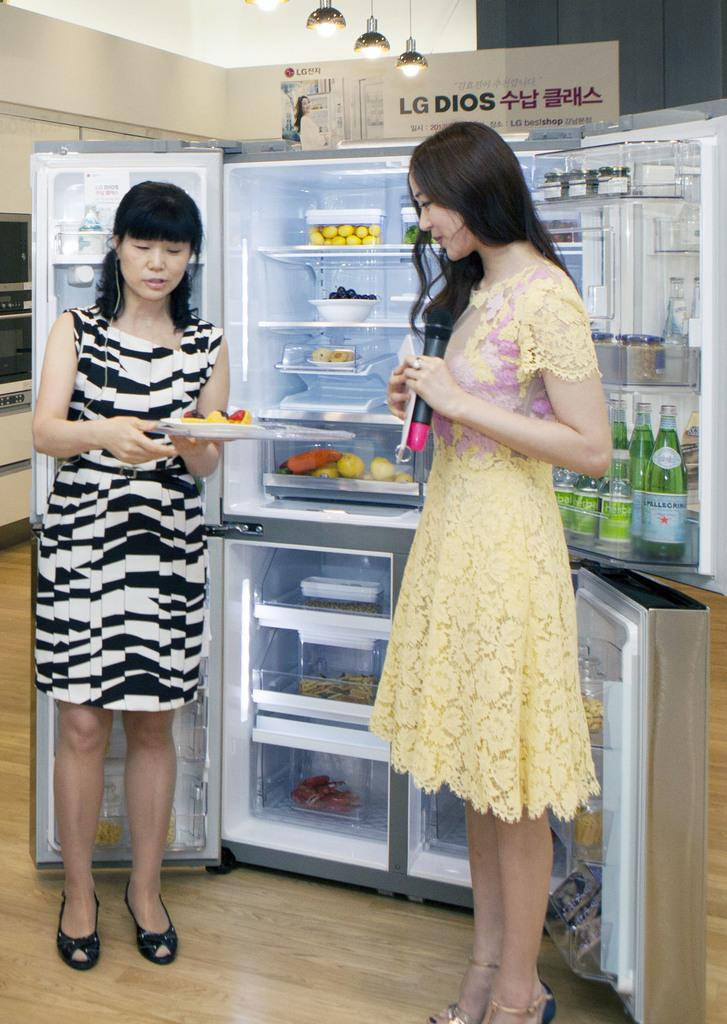How many people are in the image? There are two ladies in the image. What are the ladies holding in the image? The ladies are holding something, but the specific item is not mentioned in the facts. What is behind the ladies in the image? The ladies are standing in front of a refrigerator. What can be found inside the refrigerator? There are bottles, fruits, and other items in the refrigerator. What type of arm is visible in the image? There is no arm mentioned or visible in the image. What frame is the ladies standing in front of in the image? The ladies are standing in front of a refrigerator, not a frame. 